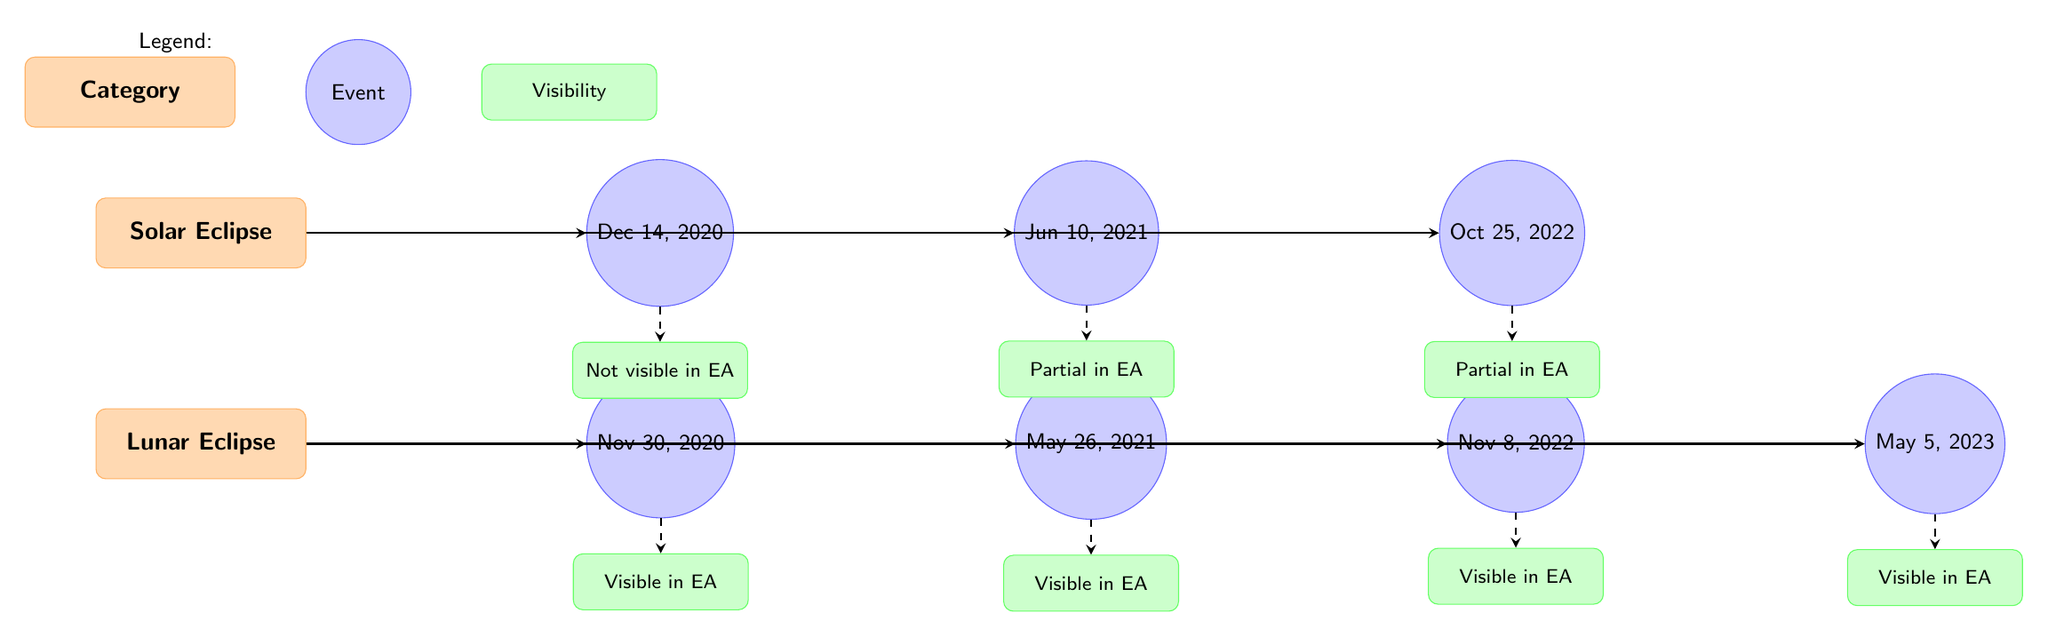What events occurred in 2021? The diagram lists two events for the year 2021 under solar and lunar eclipses: Jun 10 for the solar eclipse and May 26 for the lunar eclipse. Thus, both events occurred in 2021.
Answer: Jun 10, May 26 How many solar eclipses are shown in the diagram? There are three solar eclipse events listed in the diagram for the years 2020, 2021, and 2022.
Answer: 3 What is the visibility of the lunar eclipse on November 8, 2022? The diagram indicates that the lunar eclipse occurring on November 8, 2022, is marked as "Visible in EA," referring to East Asia.
Answer: Visible in EA Which solar eclipse is partially visible in East Asia? The diagram shows that the solar eclipse on June 10, 2021, is labeled as "Partial in EA," indicating partial visibility in East Asia.
Answer: Jun 10, 2021 What is the overall category for the event on Dec 14, 2020? The event on Dec 14, 2020, belongs to the "Solar Eclipse" category as indicated in the diagram, which is a clear categorization of solar events.
Answer: Solar Eclipse How many lunar eclipses are visible in East Asia from 2020 to 2023? The diagram lists four lunar eclipses from 2020 to 2023, all marked as "Visible in EA," thus indicating that all can be seen from East Asia.
Answer: 4 What is the relationship between the solar eclipse on October 25, 2022 and its visibility? The visibility node below the solar event on October 25, 2022, states "Partial in EA," showing that it is connected to the visibility label by a dashed arrow.
Answer: Partial in EA What type of eclipse is the event on May 5, 2023? The event on May 5, 2023, is classified as a lunar eclipse based on its placement under the lunar category in the diagram.
Answer: Lunar Eclipse 